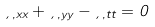Convert formula to latex. <formula><loc_0><loc_0><loc_500><loc_500>\xi _ { , x x } + \xi _ { , y y } - \xi _ { , t t } = 0</formula> 